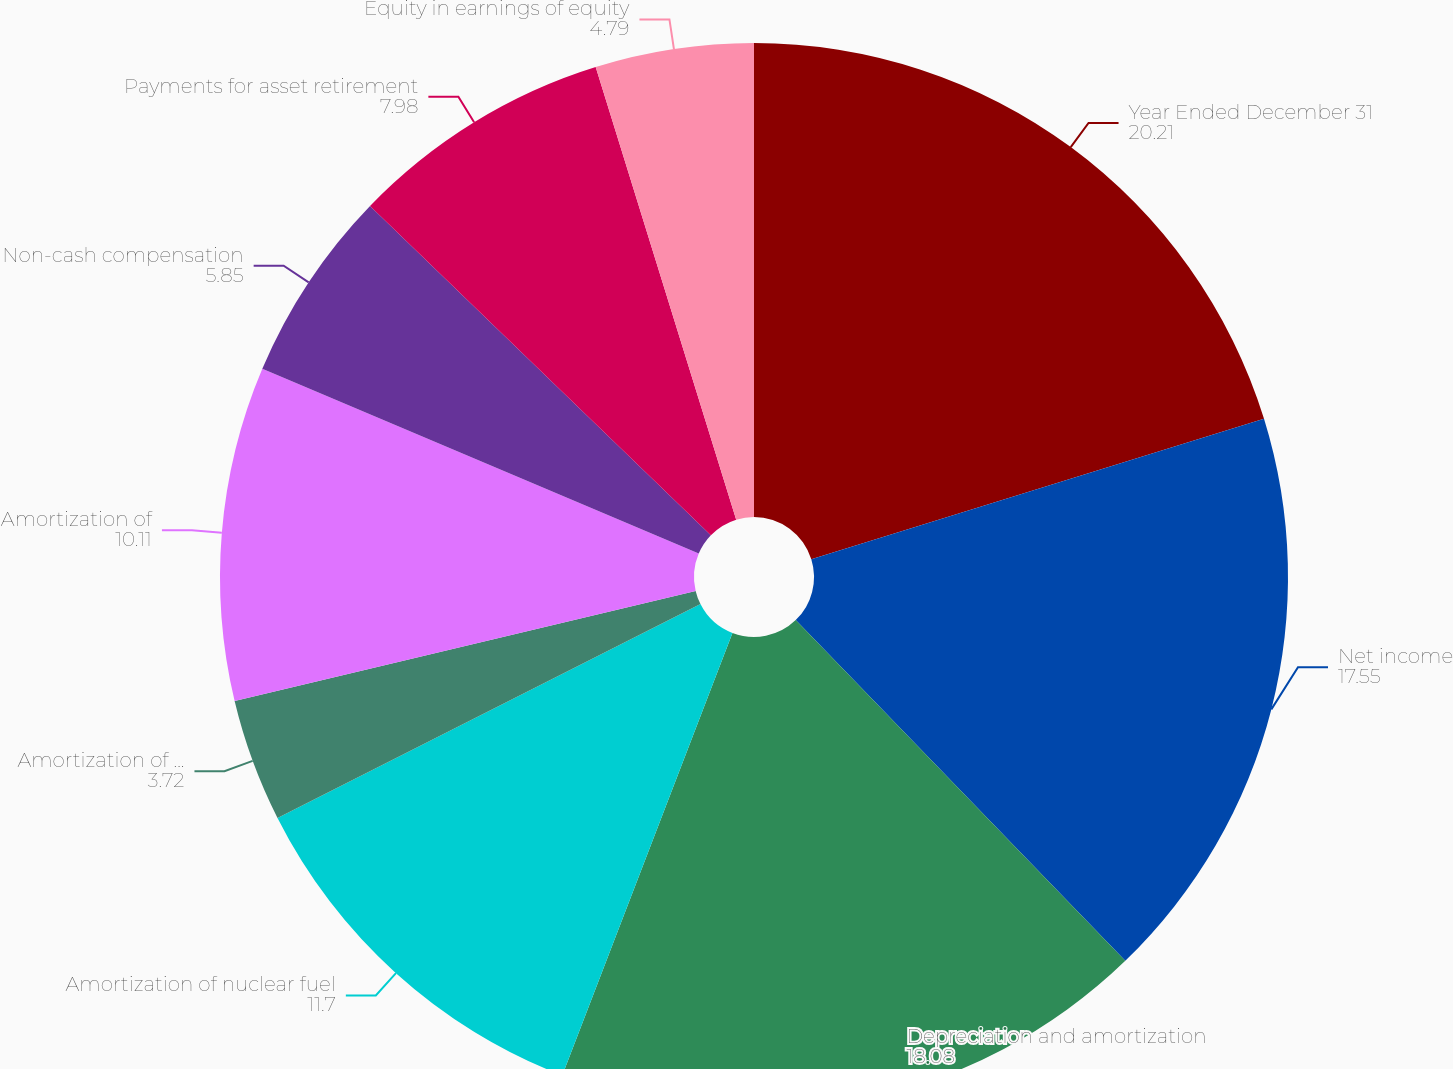Convert chart to OTSL. <chart><loc_0><loc_0><loc_500><loc_500><pie_chart><fcel>Year Ended December 31<fcel>Net income<fcel>Depreciation and amortization<fcel>Amortization of nuclear fuel<fcel>Amortization of deferred<fcel>Amortization of<fcel>Non-cash compensation<fcel>Payments for asset retirement<fcel>Equity in earnings of equity<nl><fcel>20.21%<fcel>17.55%<fcel>18.08%<fcel>11.7%<fcel>3.72%<fcel>10.11%<fcel>5.85%<fcel>7.98%<fcel>4.79%<nl></chart> 